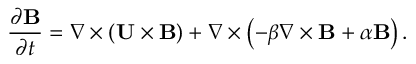<formula> <loc_0><loc_0><loc_500><loc_500>\frac { \partial { B } } { \partial t } = \nabla \times \left ( { { U } \times { B } } \right ) + \nabla \times \left ( { - \beta \nabla \times { B } + \alpha { B } } \right ) .</formula> 